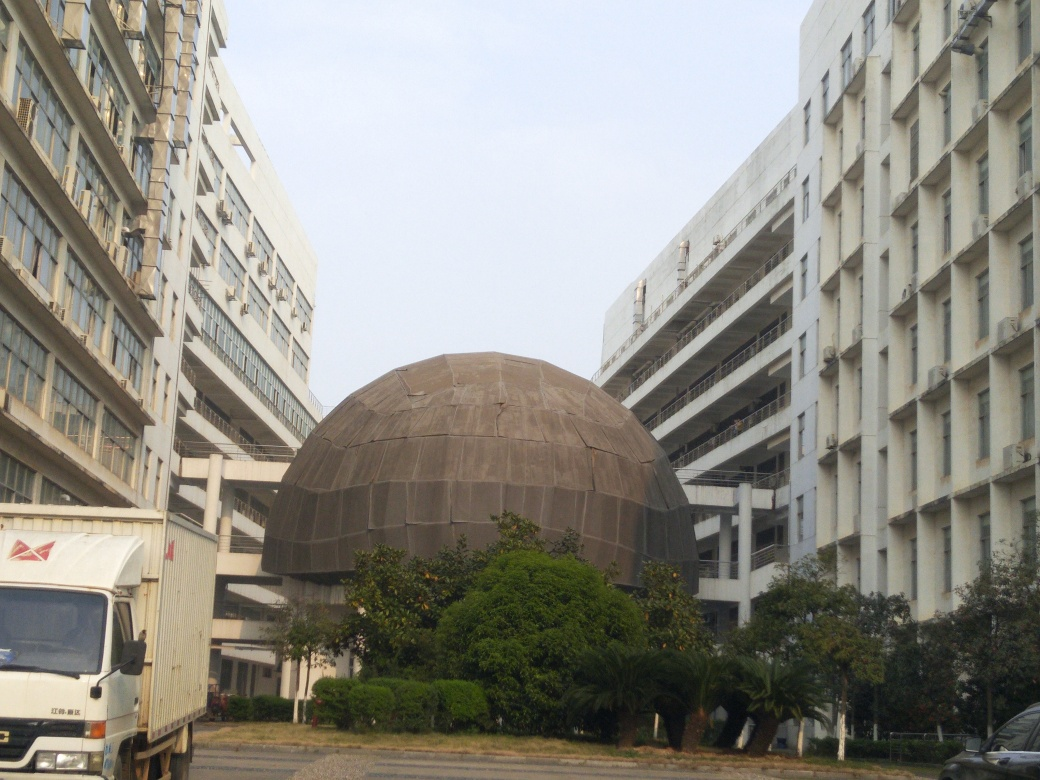How could this urban space be improved aesthetically? Aesthetic improvements to this urban space could include the incorporation of more greenery, such as trees and landscaped areas, to add color and soften the harsh lines of the buildings. Public art installations or water features could provide focal points and enhance visual interest. Additionally, updating building facades with contemporary materials or colors might also renew the area's appeal. 